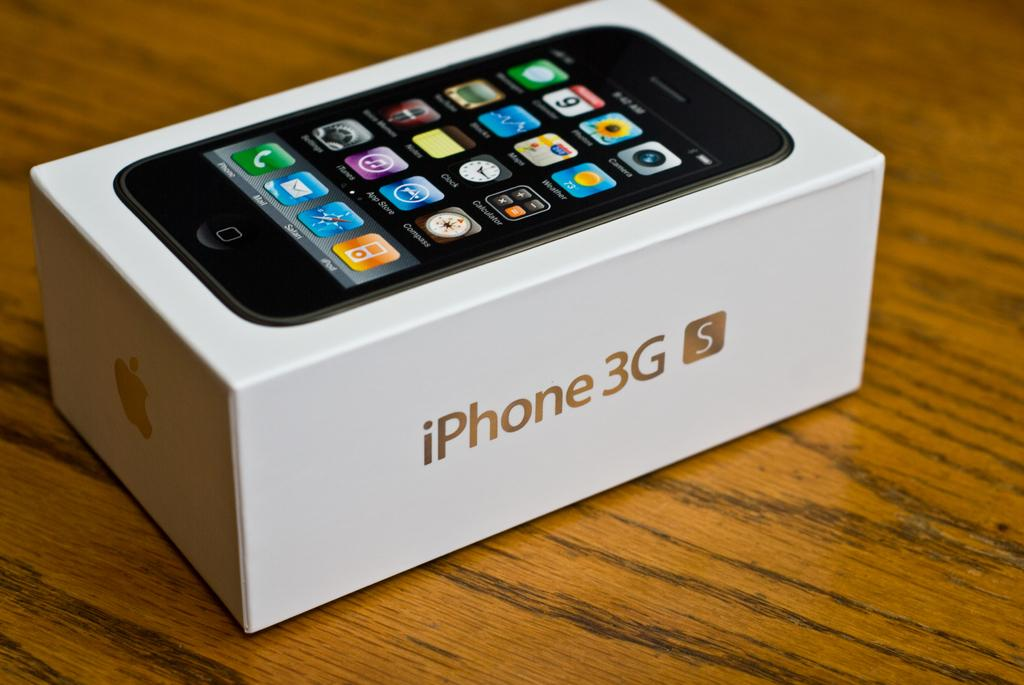<image>
Relay a brief, clear account of the picture shown. A box of iPhone 3G S placed on a table. 